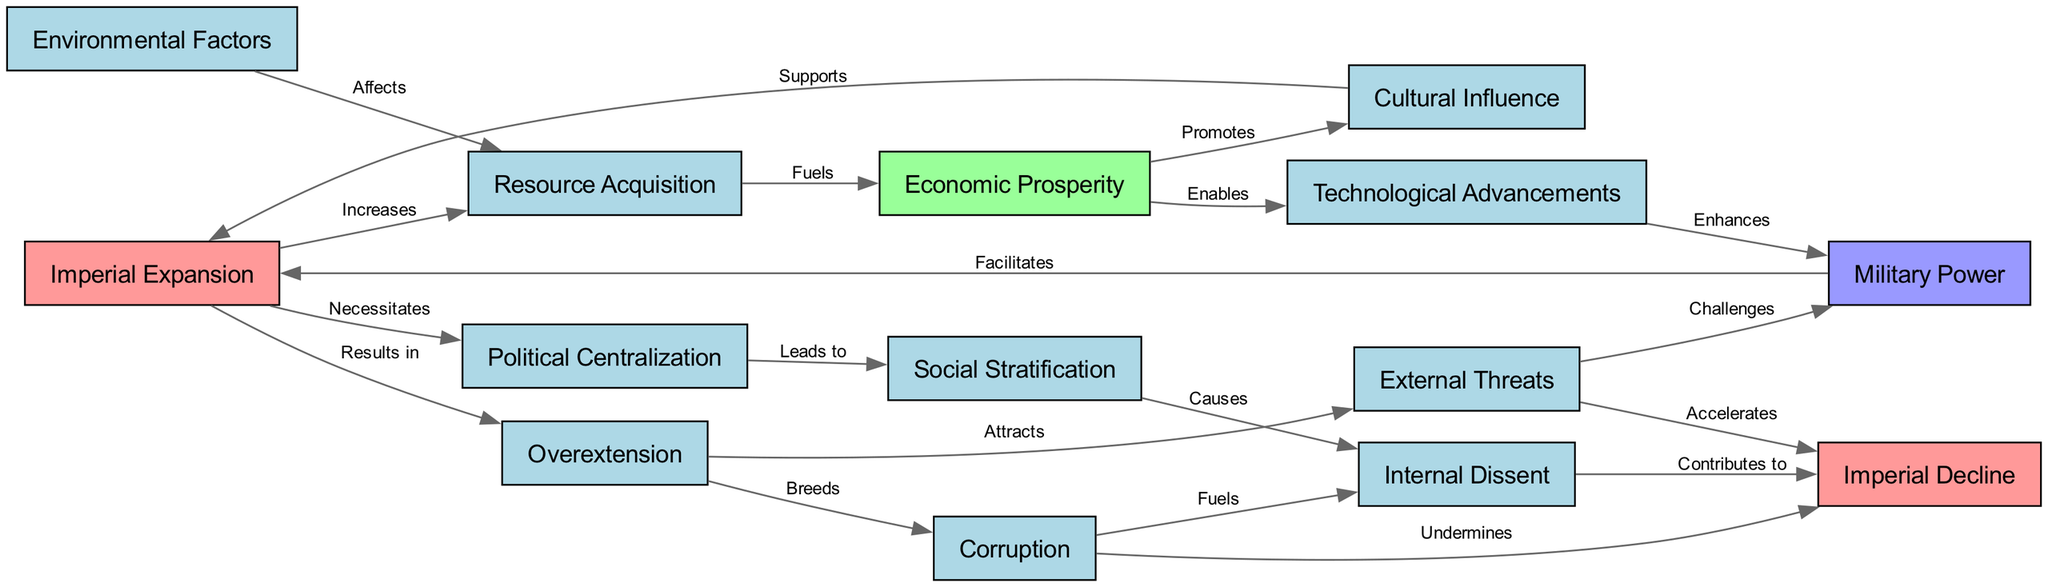What is the initial node that contributes to resource acquisition? The diagram indicates that "Imperial Expansion" contributes to "Resource Acquisition." This is established by following the directed edge labeled "Increases" from "Imperial Expansion" to "Resource Acquisition."
Answer: Imperial Expansion How many nodes are involved in the diagram? To determine the number of nodes, we can count each unique factor listed under the nodes section. There are 14 distinct factors contributing to the rise and fall of empires.
Answer: 14 Which two nodes are directly connected by the edge labeled "Challenges"? By examining the edges, the edge labeled "Challenges" connects "External Threats" to "Military Power." This relationship indicates that external threats create challenges for military power.
Answer: External Threats and Military Power What leads to social stratification according to the diagram? The diagram shows that "Political Centralization" leads to "Social Stratification." By following the edge from "Political Centralization" to "Social Stratification," we can confirm this relationship.
Answer: Political Centralization Which factor is shown to contribute to imperial decline through internal dissent? The diagram specifies that "Internal Dissent" is a contributing factor to "Imperial Decline." Similarly, it indicates this relationship via the directed edge labeled "Contributes to."
Answer: Internal Dissent How does overextension affect corruption? According to the diagram, "Overextension" breeds "Corruption." This causal relationship can be traced through the edge labeled "Breeds," which connects these two nodes.
Answer: Breeds What type of influence does economic prosperity promote? The flow of the diagram indicates that "Economic Prosperity" promotes "Cultural Influence." This can be identified by the edge that directly connects these two nodes with a corresponding label.
Answer: Cultural Influence Which factors accelerate imperial decline? The diagram indicates that both "External Threats" and "Corruption" accelerate "Imperial Decline." This is evidenced by edges labeled "Accelerates" that lead from both factors to the decline node.
Answer: External Threats and Corruption 